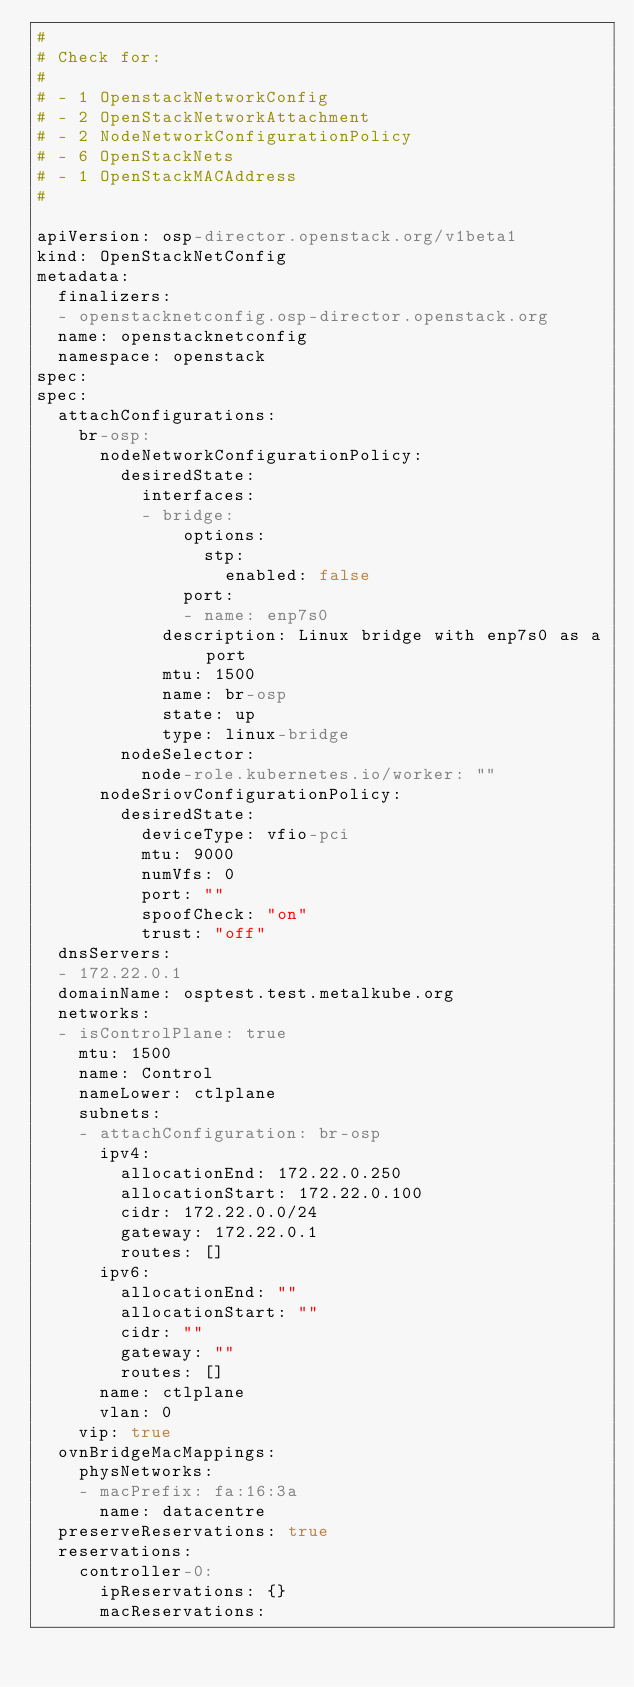Convert code to text. <code><loc_0><loc_0><loc_500><loc_500><_YAML_>#
# Check for:
#
# - 1 OpenstackNetworkConfig
# - 2 OpenStackNetworkAttachment
# - 2 NodeNetworkConfigurationPolicy
# - 6 OpenStackNets
# - 1 OpenStackMACAddress
#

apiVersion: osp-director.openstack.org/v1beta1
kind: OpenStackNetConfig
metadata:
  finalizers:
  - openstacknetconfig.osp-director.openstack.org
  name: openstacknetconfig
  namespace: openstack
spec:
spec:
  attachConfigurations:
    br-osp:
      nodeNetworkConfigurationPolicy:
        desiredState:
          interfaces:
          - bridge:
              options:
                stp:
                  enabled: false
              port:
              - name: enp7s0
            description: Linux bridge with enp7s0 as a port
            mtu: 1500
            name: br-osp
            state: up
            type: linux-bridge
        nodeSelector:
          node-role.kubernetes.io/worker: ""
      nodeSriovConfigurationPolicy:
        desiredState:
          deviceType: vfio-pci
          mtu: 9000
          numVfs: 0
          port: ""
          spoofCheck: "on"
          trust: "off"
  dnsServers:
  - 172.22.0.1
  domainName: osptest.test.metalkube.org
  networks:
  - isControlPlane: true
    mtu: 1500
    name: Control
    nameLower: ctlplane
    subnets:
    - attachConfiguration: br-osp
      ipv4:
        allocationEnd: 172.22.0.250
        allocationStart: 172.22.0.100
        cidr: 172.22.0.0/24
        gateway: 172.22.0.1
        routes: []
      ipv6:
        allocationEnd: ""
        allocationStart: ""
        cidr: ""
        gateway: ""
        routes: []
      name: ctlplane
      vlan: 0
    vip: true
  ovnBridgeMacMappings:
    physNetworks:
    - macPrefix: fa:16:3a
      name: datacentre
  preserveReservations: true
  reservations:
    controller-0:
      ipReservations: {}
      macReservations:</code> 